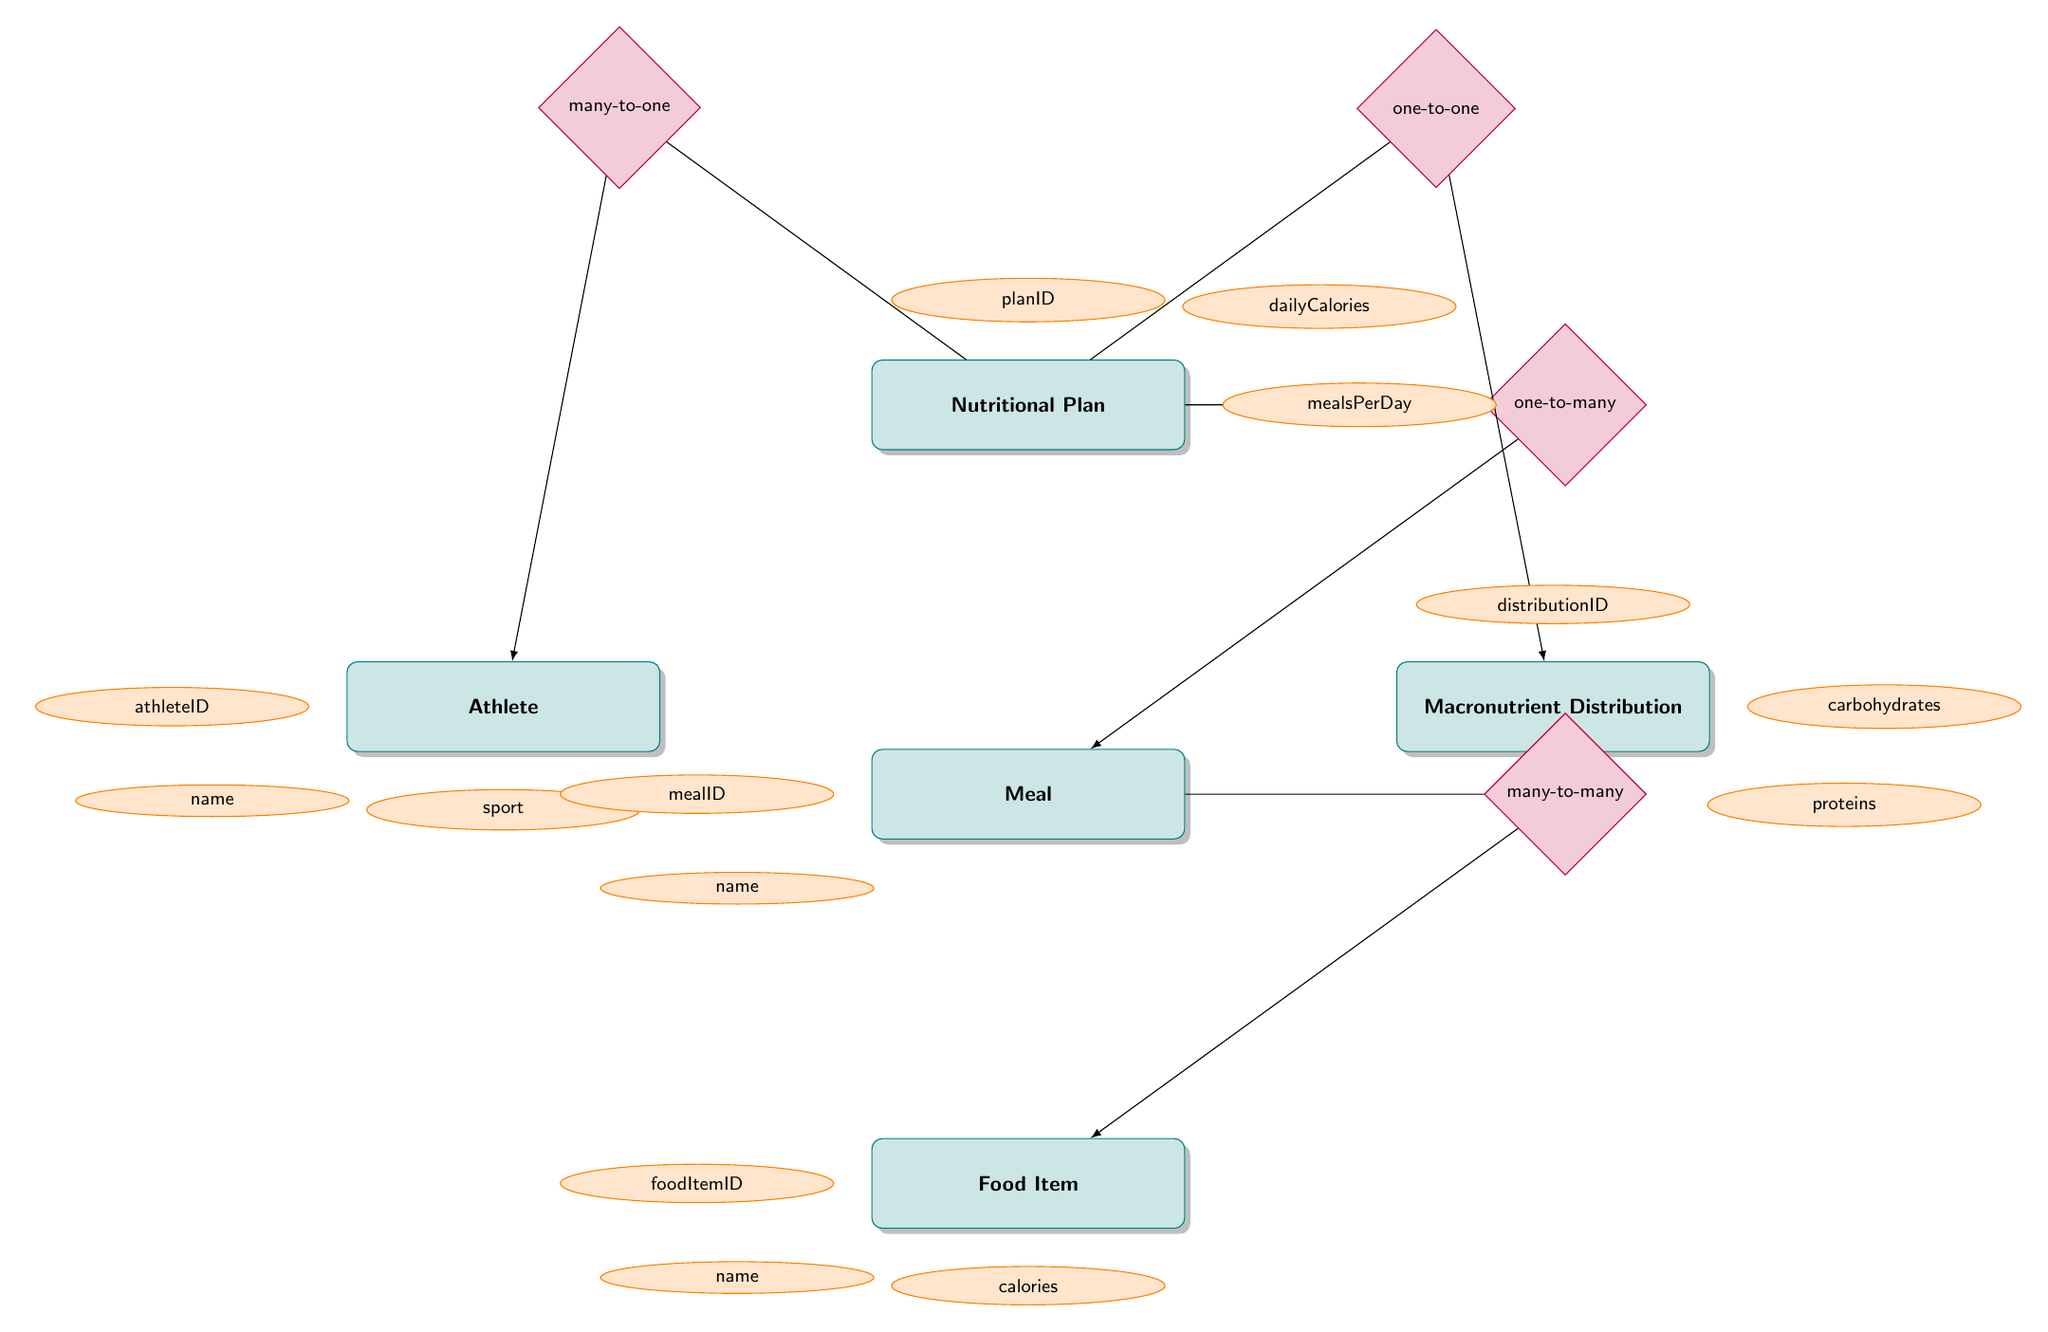What is the primary relationship type between Nutritional Plan and Athlete? The diagram shows a many-to-one relationship between Nutritional Plan and Athlete, meaning that multiple nutritional plans can be associated with a single athlete.
Answer: many-to-one How many attributes does the Meal entity have? The Meal entity in the diagram has two defined attributes: mealID and name. This can be counted directly from the Meal box in the diagram.
Answer: 2 What is the unique identifier for Macronutrient Distribution? The unique identifier for Macronutrient Distribution is specified as distributionID, which can be found in the attributes listed under the Macronutrient Distribution entity.
Answer: distributionID Which entity is connected to Food Item through a many-to-many relationship? The Meal entity is connected to the Food Item entity through a many-to-many relationship, as indicated by the relationship diamond between these two entities.
Answer: Meal What is the connection type between Nutritional Plan and Macronutrient Distribution? The connection type between Nutritional Plan and Macronutrient Distribution is one-to-one, meaning that each nutritional plan is associated with exactly one macronutrient distribution.
Answer: one-to-one How many entities are present in the diagram? Counting the entities shown in the diagram, there are five entities: Nutritional Plan, Athlete, Macronutrient Distribution, Meal, and Food Item.
Answer: 5 What type of information does the Athlete entity provide? The Athlete entity provides specific athlete information such as athleteID, name, sport, trainingHoursPerWeek, and fitnessLevel, following the attributes listed.
Answer: athlete information What is the hydration level parameter in relation to the Nutritional Plan? The hydration level in the Nutritional Plan is an attribute that indicates the recommended hydration level for the athlete, as it is one of the parameters listed for the Nutritional Plan entity.
Answer: hydration level 